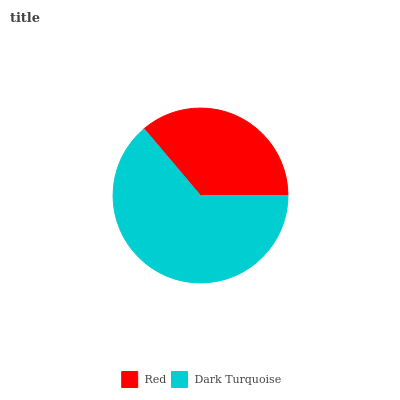Is Red the minimum?
Answer yes or no. Yes. Is Dark Turquoise the maximum?
Answer yes or no. Yes. Is Dark Turquoise the minimum?
Answer yes or no. No. Is Dark Turquoise greater than Red?
Answer yes or no. Yes. Is Red less than Dark Turquoise?
Answer yes or no. Yes. Is Red greater than Dark Turquoise?
Answer yes or no. No. Is Dark Turquoise less than Red?
Answer yes or no. No. Is Dark Turquoise the high median?
Answer yes or no. Yes. Is Red the low median?
Answer yes or no. Yes. Is Red the high median?
Answer yes or no. No. Is Dark Turquoise the low median?
Answer yes or no. No. 